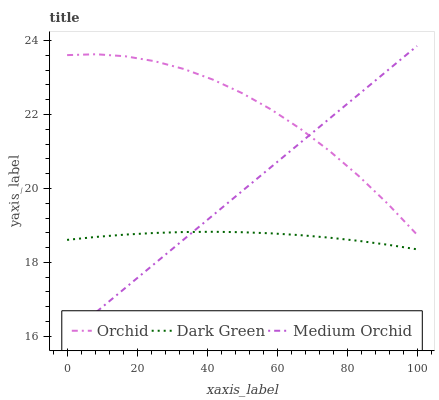Does Dark Green have the minimum area under the curve?
Answer yes or no. Yes. Does Orchid have the maximum area under the curve?
Answer yes or no. Yes. Does Orchid have the minimum area under the curve?
Answer yes or no. No. Does Dark Green have the maximum area under the curve?
Answer yes or no. No. Is Medium Orchid the smoothest?
Answer yes or no. Yes. Is Orchid the roughest?
Answer yes or no. Yes. Is Dark Green the smoothest?
Answer yes or no. No. Is Dark Green the roughest?
Answer yes or no. No. Does Medium Orchid have the lowest value?
Answer yes or no. Yes. Does Dark Green have the lowest value?
Answer yes or no. No. Does Medium Orchid have the highest value?
Answer yes or no. Yes. Does Orchid have the highest value?
Answer yes or no. No. Is Dark Green less than Orchid?
Answer yes or no. Yes. Is Orchid greater than Dark Green?
Answer yes or no. Yes. Does Medium Orchid intersect Orchid?
Answer yes or no. Yes. Is Medium Orchid less than Orchid?
Answer yes or no. No. Is Medium Orchid greater than Orchid?
Answer yes or no. No. Does Dark Green intersect Orchid?
Answer yes or no. No. 